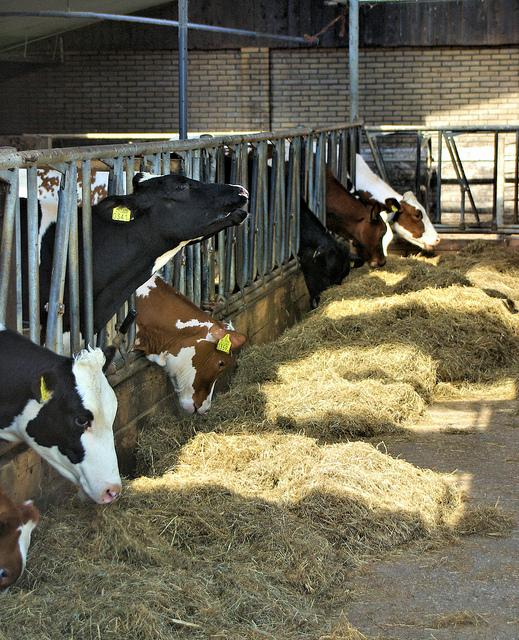Which way is the black cow with yellow tag facing? Please explain your reasoning. west. The cow with the tag is probably facing west since the sun is in that direction. 